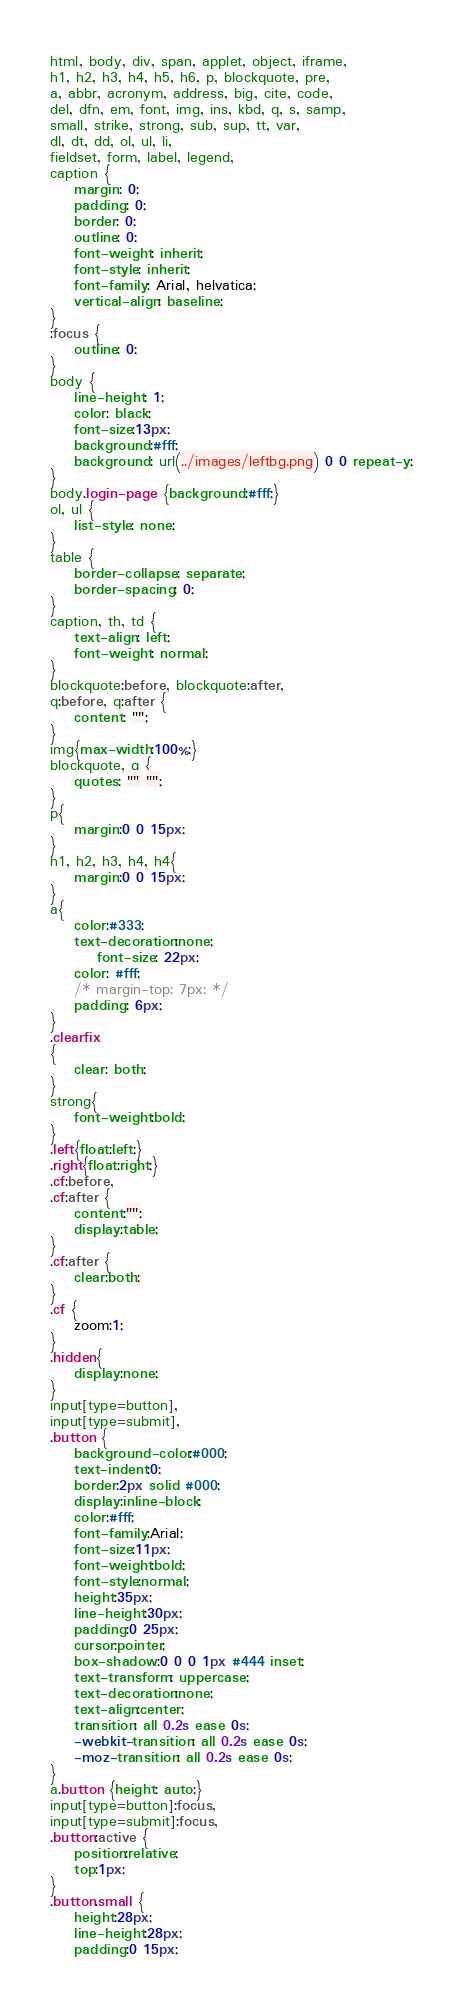Convert code to text. <code><loc_0><loc_0><loc_500><loc_500><_CSS_>html, body, div, span, applet, object, iframe,
h1, h2, h3, h4, h5, h6, p, blockquote, pre,
a, abbr, acronym, address, big, cite, code,
del, dfn, em, font, img, ins, kbd, q, s, samp,
small, strike, strong, sub, sup, tt, var,
dl, dt, dd, ol, ul, li,
fieldset, form, label, legend,
caption {
	margin: 0;
	padding: 0;
	border: 0;
	outline: 0;
	font-weight: inherit;
	font-style: inherit;
	font-family: Arial, helvatica;
	vertical-align: baseline;
}
:focus {
	outline: 0;
}
body {
	line-height: 1;
	color: black;
	font-size:13px;
	background:#fff;
	background: url(../images/leftbg.png) 0 0 repeat-y;
}
body.login-page {background:#fff;}
ol, ul {
	list-style: none;
}
table {
	border-collapse: separate;
	border-spacing: 0;
}
caption, th, td {
	text-align: left;
	font-weight: normal;
}
blockquote:before, blockquote:after,
q:before, q:after {
	content: "";
}
img{max-width:100%;}
blockquote, q {
	quotes: "" "";
}
p{
	margin:0 0 15px;
}
h1, h2, h3, h4, h4{
	margin:0 0 15px;
}
a{
	color:#333;
	text-decoration:none;
	    font-size: 22px;
    color: #fff;
    /* margin-top: 7px; */
    padding: 6px;
}
.clearfix
{
	clear: both;
}
strong{
	font-weight:bold;
}
.left{float:left;}
.right{float:right;}
.cf:before,
.cf:after {
    content:"";
    display:table;
}
.cf:after {
    clear:both;
}
.cf {
    zoom:1;
}
.hidden{
	display:none;
}
input[type=button],
input[type=submit],
.button {
	background-color:#000;
	text-indent:0;
	border:2px solid #000;
	display:inline-block;
	color:#fff;
	font-family:Arial;
	font-size:11px;
	font-weight:bold;
	font-style:normal;
	height:35px;
	line-height:30px;
	padding:0 25px;
	cursor:pointer;
	box-shadow:0 0 0 1px #444 inset;
	text-transform: uppercase;
	text-decoration:none;
	text-align:center;
	transition: all 0.2s ease 0s;
	-webkit-transition: all 0.2s ease 0s;
	-moz-transition: all 0.2s ease 0s;
}
a.button {height: auto;}
input[type=button]:focus,
input[type=submit]:focus,
.button:active {
	position:relative;
	top:1px;
}
.button.small {
	height:28px;
	line-height:28px;
	padding:0 15px;</code> 